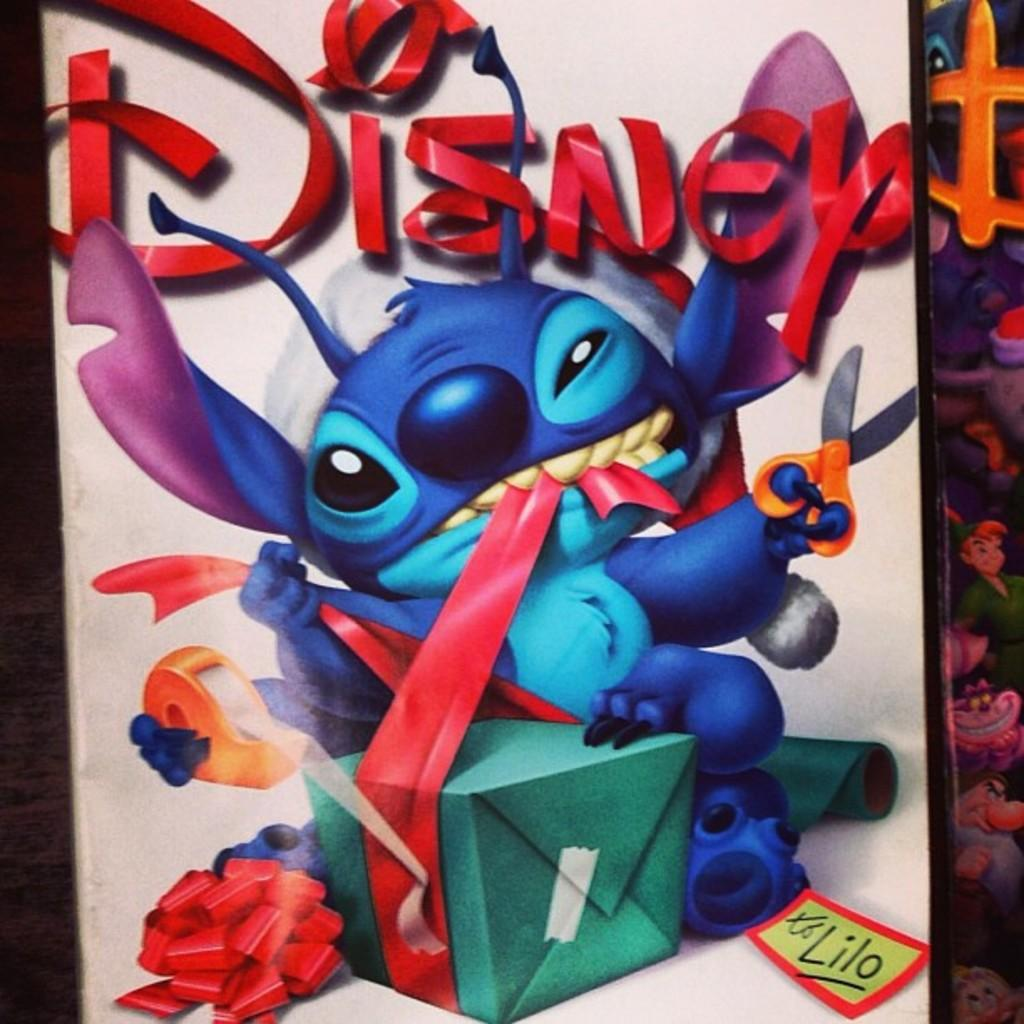What is the main subject in the center of the image? There is a card in the center of the image. What type of image is on the card? There is a cartoon on the card. What type of worm can be seen crawling on the card in the image? There is no worm present on the card in the image. 